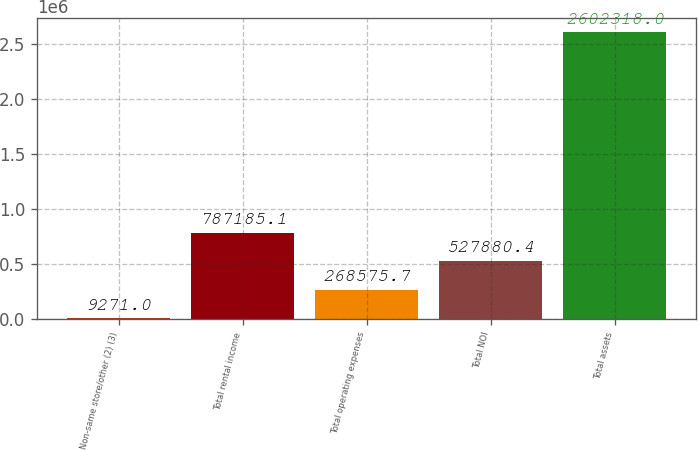<chart> <loc_0><loc_0><loc_500><loc_500><bar_chart><fcel>Non-same store/other (2) (3)<fcel>Total rental income<fcel>Total operating expenses<fcel>Total NOI<fcel>Total assets<nl><fcel>9271<fcel>787185<fcel>268576<fcel>527880<fcel>2.60232e+06<nl></chart> 